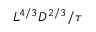<formula> <loc_0><loc_0><loc_500><loc_500>L ^ { 4 / 3 } D ^ { 2 / 3 } / \tau</formula> 